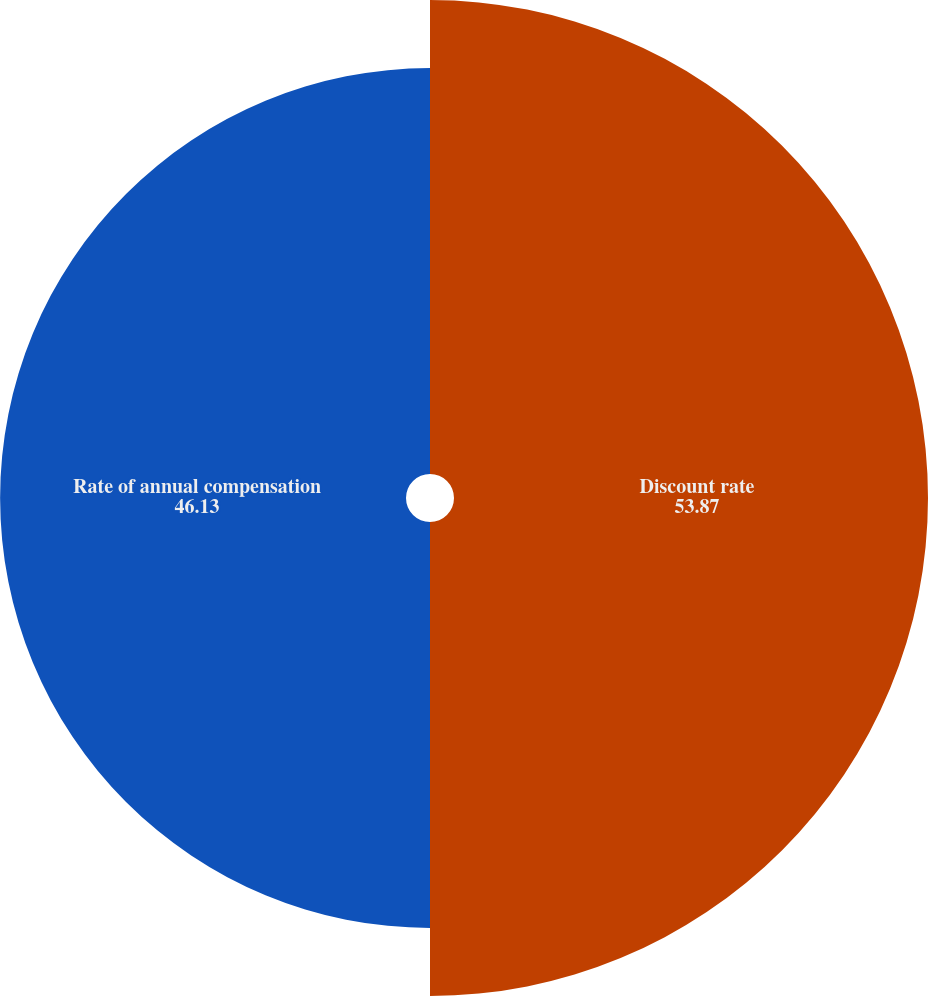Convert chart. <chart><loc_0><loc_0><loc_500><loc_500><pie_chart><fcel>Discount rate<fcel>Rate of annual compensation<nl><fcel>53.87%<fcel>46.13%<nl></chart> 